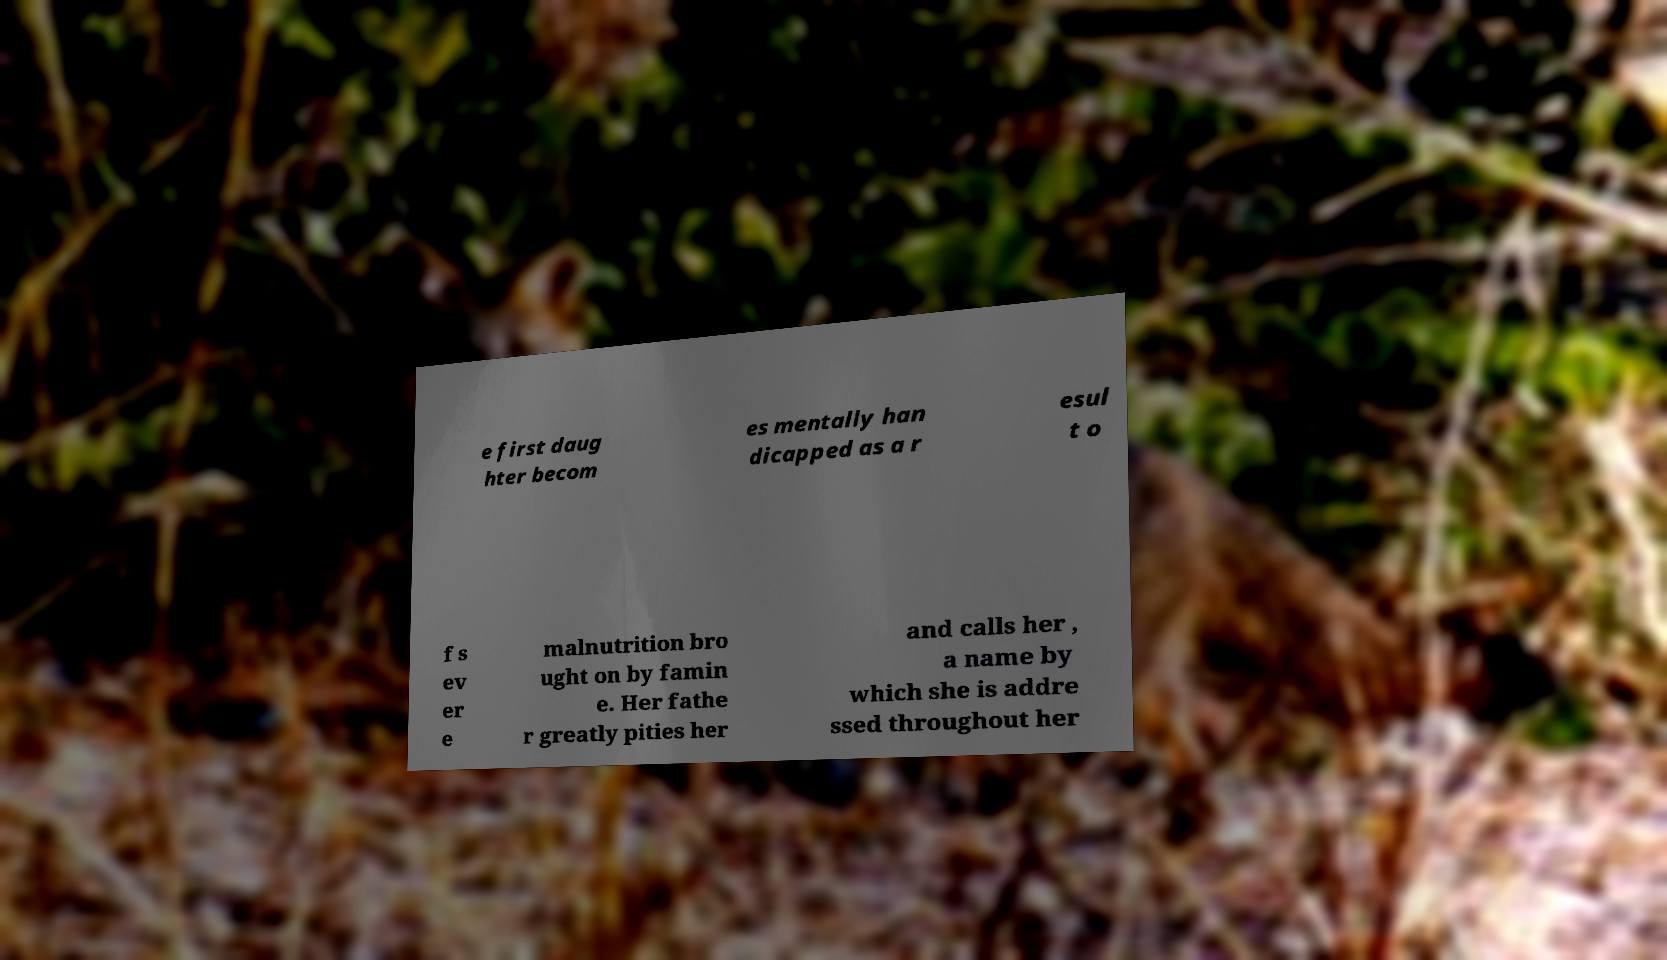Can you read and provide the text displayed in the image?This photo seems to have some interesting text. Can you extract and type it out for me? e first daug hter becom es mentally han dicapped as a r esul t o f s ev er e malnutrition bro ught on by famin e. Her fathe r greatly pities her and calls her , a name by which she is addre ssed throughout her 